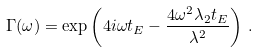<formula> <loc_0><loc_0><loc_500><loc_500>\Gamma ( \omega ) = \exp \left ( 4 i \omega t _ { E } - \frac { 4 \omega ^ { 2 } \lambda _ { 2 } t _ { E } } { \lambda ^ { 2 } } \right ) \, .</formula> 